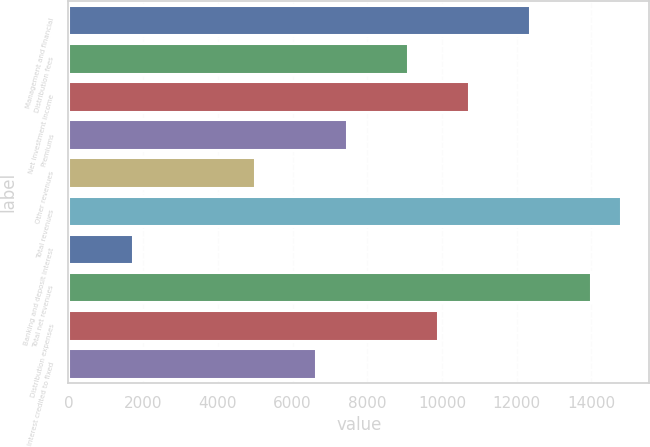Convert chart to OTSL. <chart><loc_0><loc_0><loc_500><loc_500><bar_chart><fcel>Management and financial<fcel>Distribution fees<fcel>Net investment income<fcel>Premiums<fcel>Other revenues<fcel>Total revenues<fcel>Banking and deposit interest<fcel>Total net revenues<fcel>Distribution expenses<fcel>Interest credited to fixed<nl><fcel>12356<fcel>9088<fcel>10722<fcel>7454<fcel>5003<fcel>14807<fcel>1735<fcel>13990<fcel>9905<fcel>6637<nl></chart> 